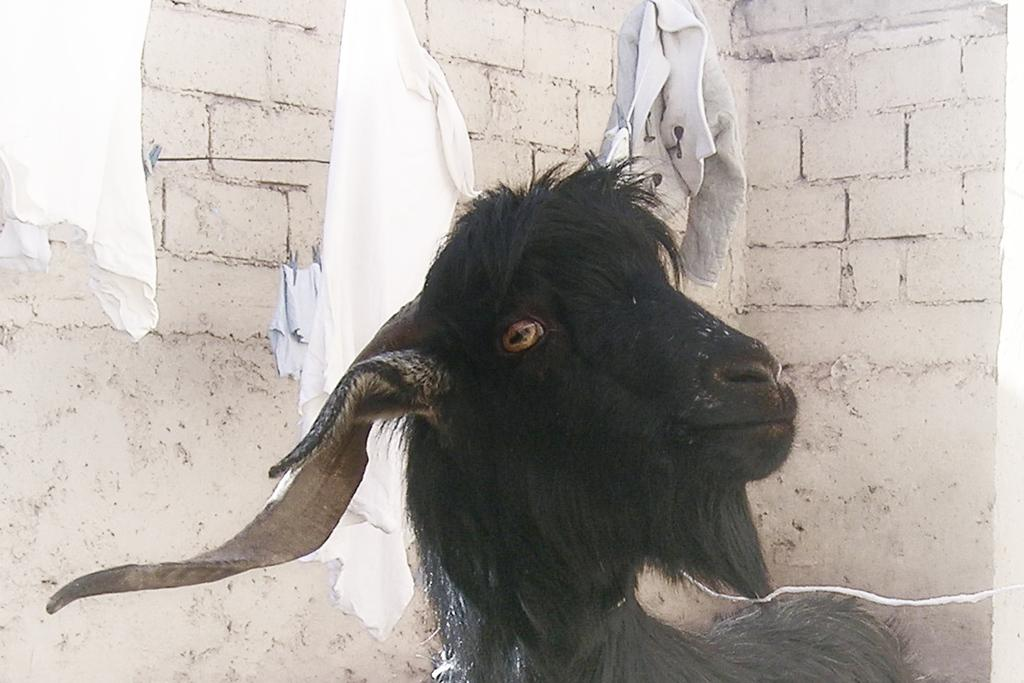What type of animal is in the image? The type of animal cannot be determined from the provided facts. What kind of structure is visible in the image? There are brick walls in the image. What else can be seen in the image besides the animal and brick walls? There are clothes in the image. What type of vessel is used to increase the animal's anger in the image? There is no vessel or indication of anger present in the image. 